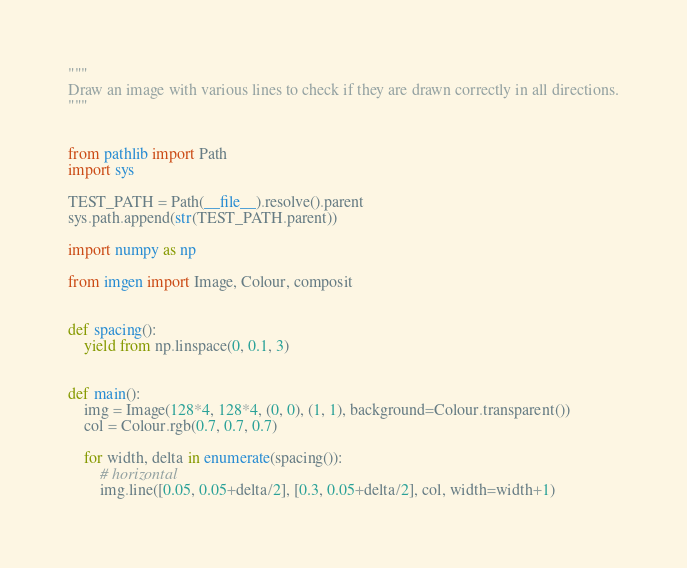<code> <loc_0><loc_0><loc_500><loc_500><_Python_>"""
Draw an image with various lines to check if they are drawn correctly in all directions.
"""


from pathlib import Path
import sys

TEST_PATH = Path(__file__).resolve().parent
sys.path.append(str(TEST_PATH.parent))

import numpy as np

from imgen import Image, Colour, composit


def spacing():
    yield from np.linspace(0, 0.1, 3)


def main():
    img = Image(128*4, 128*4, (0, 0), (1, 1), background=Colour.transparent())
    col = Colour.rgb(0.7, 0.7, 0.7)

    for width, delta in enumerate(spacing()):
        # horizontal
        img.line([0.05, 0.05+delta/2], [0.3, 0.05+delta/2], col, width=width+1)</code> 